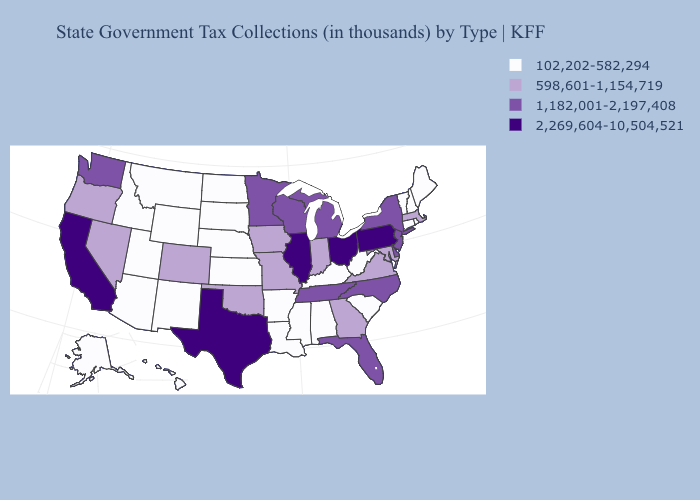What is the value of Maryland?
Be succinct. 598,601-1,154,719. Does Mississippi have the highest value in the South?
Give a very brief answer. No. What is the value of Rhode Island?
Keep it brief. 102,202-582,294. What is the lowest value in the USA?
Quick response, please. 102,202-582,294. Name the states that have a value in the range 2,269,604-10,504,521?
Quick response, please. California, Illinois, Ohio, Pennsylvania, Texas. Among the states that border Massachusetts , which have the highest value?
Give a very brief answer. New York. What is the value of Virginia?
Answer briefly. 598,601-1,154,719. Does the first symbol in the legend represent the smallest category?
Short answer required. Yes. Name the states that have a value in the range 1,182,001-2,197,408?
Quick response, please. Delaware, Florida, Michigan, Minnesota, New Jersey, New York, North Carolina, Tennessee, Washington, Wisconsin. What is the value of Connecticut?
Answer briefly. 102,202-582,294. Which states have the highest value in the USA?
Answer briefly. California, Illinois, Ohio, Pennsylvania, Texas. Among the states that border Mississippi , which have the highest value?
Be succinct. Tennessee. Does Michigan have the lowest value in the MidWest?
Quick response, please. No. Among the states that border Utah , does Nevada have the highest value?
Quick response, please. Yes. Name the states that have a value in the range 2,269,604-10,504,521?
Be succinct. California, Illinois, Ohio, Pennsylvania, Texas. 